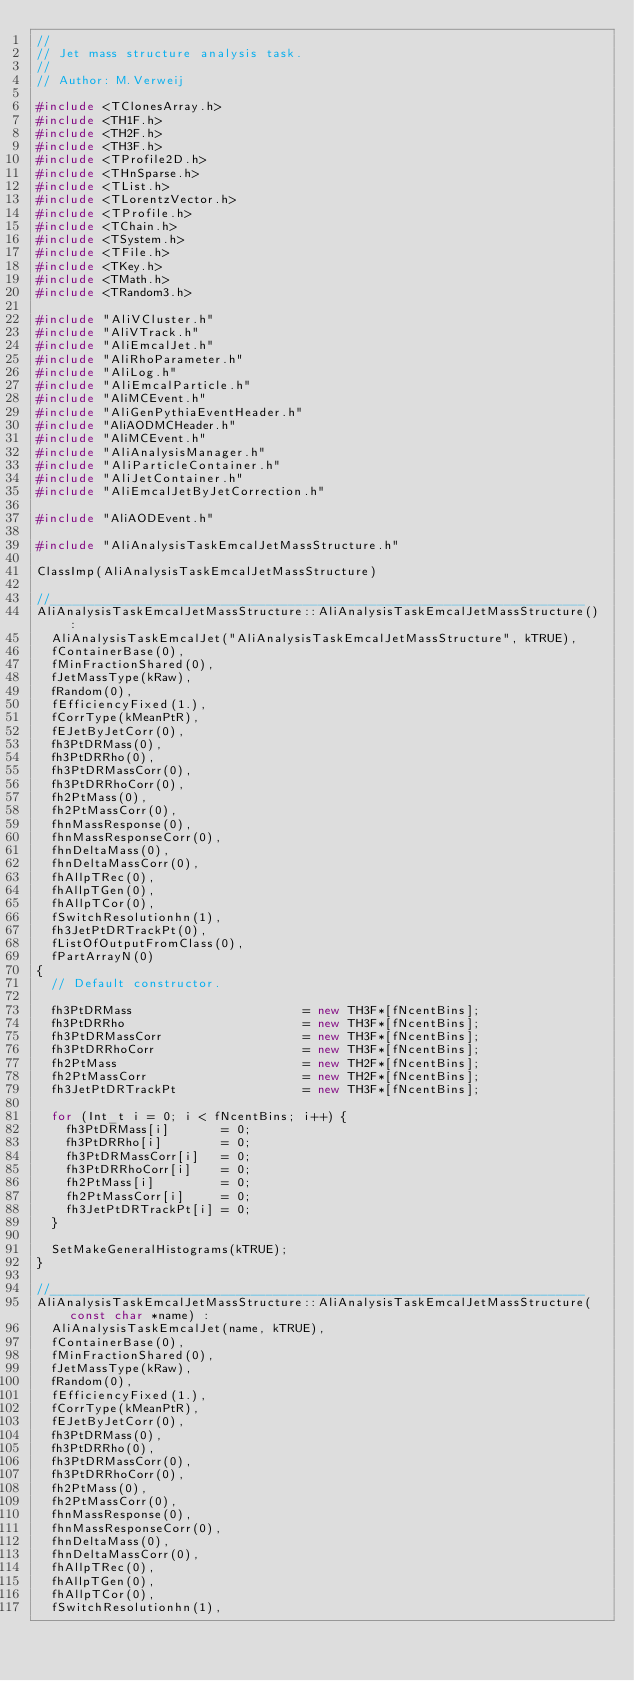Convert code to text. <code><loc_0><loc_0><loc_500><loc_500><_C++_>//
// Jet mass structure analysis task.
//
// Author: M.Verweij

#include <TClonesArray.h>
#include <TH1F.h>
#include <TH2F.h>
#include <TH3F.h>
#include <TProfile2D.h>
#include <THnSparse.h>
#include <TList.h>
#include <TLorentzVector.h>
#include <TProfile.h>
#include <TChain.h>
#include <TSystem.h>
#include <TFile.h>
#include <TKey.h>
#include <TMath.h>
#include <TRandom3.h>

#include "AliVCluster.h"
#include "AliVTrack.h"
#include "AliEmcalJet.h"
#include "AliRhoParameter.h"
#include "AliLog.h"
#include "AliEmcalParticle.h"
#include "AliMCEvent.h"
#include "AliGenPythiaEventHeader.h"
#include "AliAODMCHeader.h"
#include "AliMCEvent.h"
#include "AliAnalysisManager.h"
#include "AliParticleContainer.h"
#include "AliJetContainer.h"
#include "AliEmcalJetByJetCorrection.h"

#include "AliAODEvent.h"

#include "AliAnalysisTaskEmcalJetMassStructure.h"

ClassImp(AliAnalysisTaskEmcalJetMassStructure)

//________________________________________________________________________
AliAnalysisTaskEmcalJetMassStructure::AliAnalysisTaskEmcalJetMassStructure() : 
  AliAnalysisTaskEmcalJet("AliAnalysisTaskEmcalJetMassStructure", kTRUE),
  fContainerBase(0),
  fMinFractionShared(0),
  fJetMassType(kRaw),
  fRandom(0),
  fEfficiencyFixed(1.),
  fCorrType(kMeanPtR),
  fEJetByJetCorr(0),
  fh3PtDRMass(0),
  fh3PtDRRho(0),
  fh3PtDRMassCorr(0),
  fh3PtDRRhoCorr(0),
  fh2PtMass(0),
  fh2PtMassCorr(0),
  fhnMassResponse(0),
  fhnMassResponseCorr(0),
  fhnDeltaMass(0),     
  fhnDeltaMassCorr(0), 
  fhAllpTRec(0),
  fhAllpTGen(0),
  fhAllpTCor(0),
  fSwitchResolutionhn(1),
  fh3JetPtDRTrackPt(0),
  fListOfOutputFromClass(0),
  fPartArrayN(0)
{
  // Default constructor.

  fh3PtDRMass                       = new TH3F*[fNcentBins];
  fh3PtDRRho                        = new TH3F*[fNcentBins];
  fh3PtDRMassCorr                   = new TH3F*[fNcentBins];
  fh3PtDRRhoCorr                    = new TH3F*[fNcentBins];
  fh2PtMass                         = new TH2F*[fNcentBins];
  fh2PtMassCorr                     = new TH2F*[fNcentBins];
  fh3JetPtDRTrackPt                 = new TH3F*[fNcentBins];

  for (Int_t i = 0; i < fNcentBins; i++) {
    fh3PtDRMass[i]       = 0;
    fh3PtDRRho[i]        = 0;
    fh3PtDRMassCorr[i]   = 0;
    fh3PtDRRhoCorr[i]    = 0;
    fh2PtMass[i]         = 0;
    fh2PtMassCorr[i]     = 0;
    fh3JetPtDRTrackPt[i] = 0;
  }

  SetMakeGeneralHistograms(kTRUE);
}

//________________________________________________________________________
AliAnalysisTaskEmcalJetMassStructure::AliAnalysisTaskEmcalJetMassStructure(const char *name) : 
  AliAnalysisTaskEmcalJet(name, kTRUE),  
  fContainerBase(0),
  fMinFractionShared(0),
  fJetMassType(kRaw),
  fRandom(0),
  fEfficiencyFixed(1.),
  fCorrType(kMeanPtR),
  fEJetByJetCorr(0),
  fh3PtDRMass(0),
  fh3PtDRRho(0),
  fh3PtDRMassCorr(0),
  fh3PtDRRhoCorr(0),
  fh2PtMass(0),
  fh2PtMassCorr(0),
  fhnMassResponse(0),
  fhnMassResponseCorr(0),
  fhnDeltaMass(0),     
  fhnDeltaMassCorr(0), 
  fhAllpTRec(0),
  fhAllpTGen(0),
  fhAllpTCor(0),
  fSwitchResolutionhn(1),</code> 